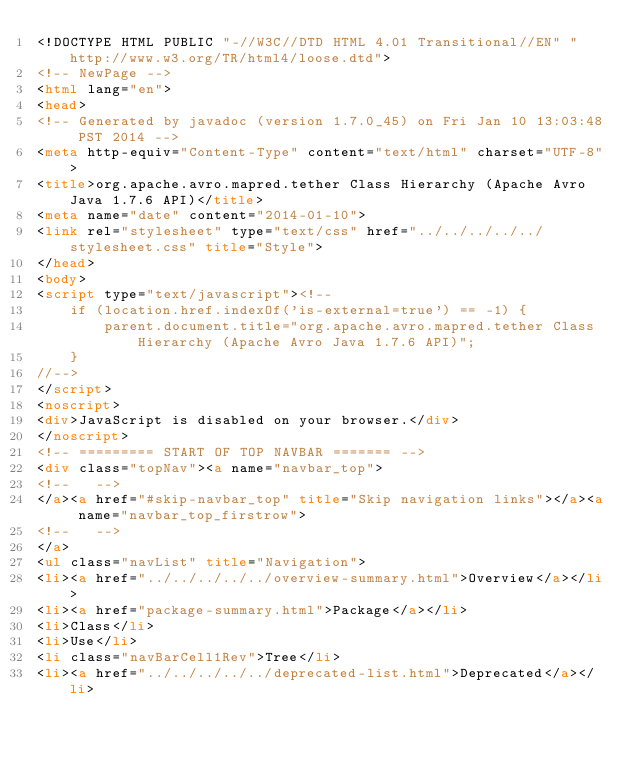<code> <loc_0><loc_0><loc_500><loc_500><_HTML_><!DOCTYPE HTML PUBLIC "-//W3C//DTD HTML 4.01 Transitional//EN" "http://www.w3.org/TR/html4/loose.dtd">
<!-- NewPage -->
<html lang="en">
<head>
<!-- Generated by javadoc (version 1.7.0_45) on Fri Jan 10 13:03:48 PST 2014 -->
<meta http-equiv="Content-Type" content="text/html" charset="UTF-8">
<title>org.apache.avro.mapred.tether Class Hierarchy (Apache Avro Java 1.7.6 API)</title>
<meta name="date" content="2014-01-10">
<link rel="stylesheet" type="text/css" href="../../../../../stylesheet.css" title="Style">
</head>
<body>
<script type="text/javascript"><!--
    if (location.href.indexOf('is-external=true') == -1) {
        parent.document.title="org.apache.avro.mapred.tether Class Hierarchy (Apache Avro Java 1.7.6 API)";
    }
//-->
</script>
<noscript>
<div>JavaScript is disabled on your browser.</div>
</noscript>
<!-- ========= START OF TOP NAVBAR ======= -->
<div class="topNav"><a name="navbar_top">
<!--   -->
</a><a href="#skip-navbar_top" title="Skip navigation links"></a><a name="navbar_top_firstrow">
<!--   -->
</a>
<ul class="navList" title="Navigation">
<li><a href="../../../../../overview-summary.html">Overview</a></li>
<li><a href="package-summary.html">Package</a></li>
<li>Class</li>
<li>Use</li>
<li class="navBarCell1Rev">Tree</li>
<li><a href="../../../../../deprecated-list.html">Deprecated</a></li></code> 